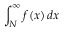Convert formula to latex. <formula><loc_0><loc_0><loc_500><loc_500>\int _ { N } ^ { \infty } f ( x ) \, d x</formula> 